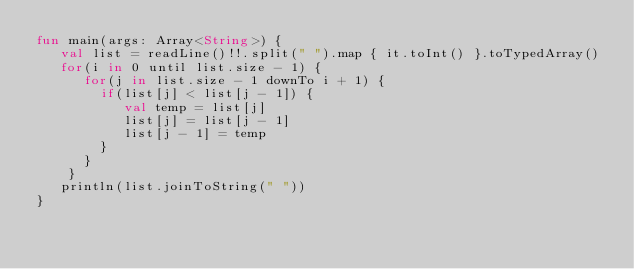<code> <loc_0><loc_0><loc_500><loc_500><_Kotlin_>fun main(args: Array<String>) {
   val list = readLine()!!.split(" ").map { it.toInt() }.toTypedArray()
   for(i in 0 until list.size - 1) {
      for(j in list.size - 1 downTo i + 1) {
        if(list[j] < list[j - 1]) {
           val temp = list[j]
           list[j] = list[j - 1]
           list[j - 1] = temp
        }
      }
    }
   println(list.joinToString(" "))
}
</code> 